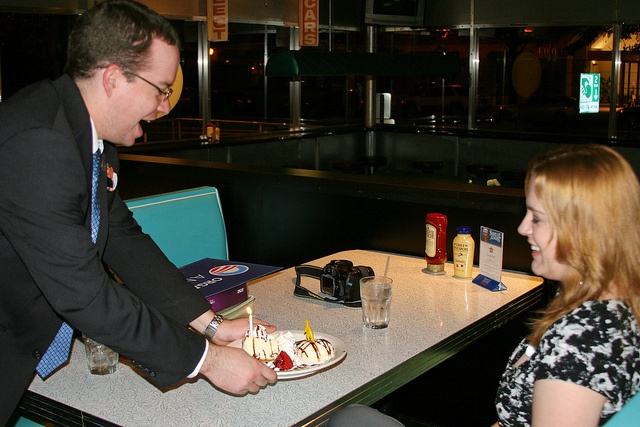Describe the objects in this image and their specific colors. I can see people in black, lightpink, brown, and maroon tones, dining table in black, darkgray, and tan tones, people in black, tan, and gray tones, chair in black and teal tones, and cake in black, beige, tan, and brown tones in this image. 